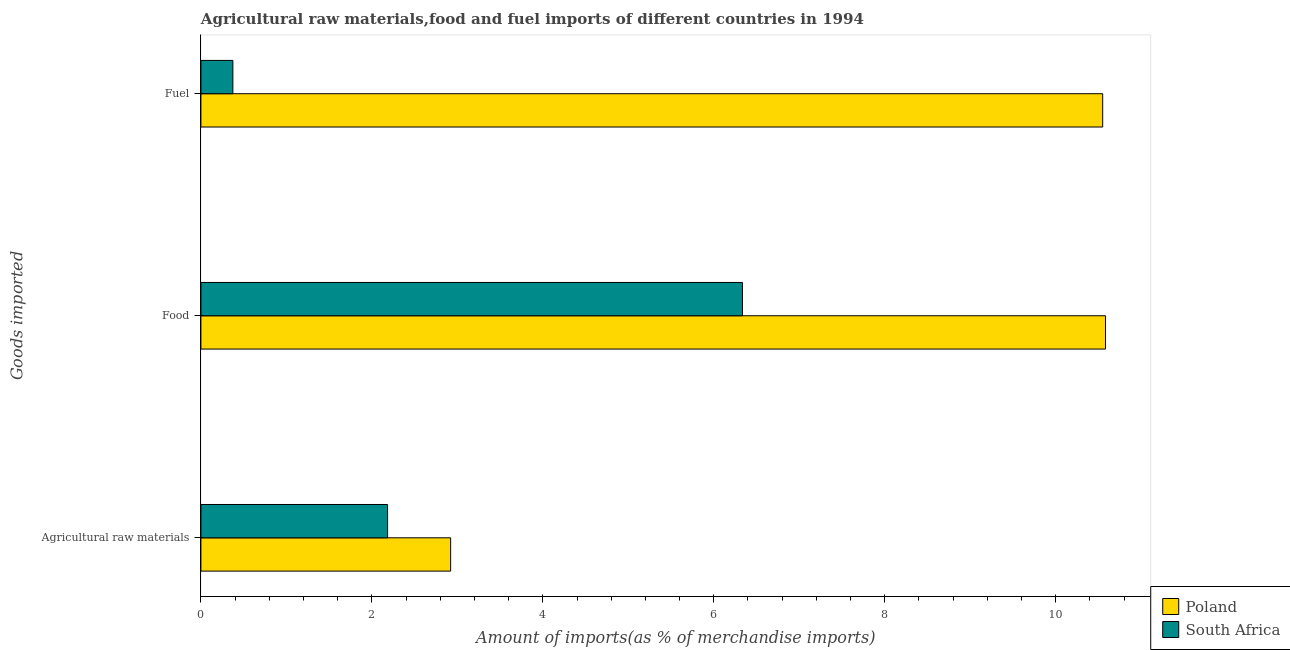What is the label of the 3rd group of bars from the top?
Your response must be concise. Agricultural raw materials. What is the percentage of fuel imports in South Africa?
Your answer should be compact. 0.37. Across all countries, what is the maximum percentage of fuel imports?
Give a very brief answer. 10.55. Across all countries, what is the minimum percentage of fuel imports?
Your answer should be very brief. 0.37. In which country was the percentage of raw materials imports minimum?
Give a very brief answer. South Africa. What is the total percentage of raw materials imports in the graph?
Your answer should be very brief. 5.11. What is the difference between the percentage of raw materials imports in Poland and that in South Africa?
Keep it short and to the point. 0.74. What is the difference between the percentage of food imports in South Africa and the percentage of fuel imports in Poland?
Ensure brevity in your answer.  -4.21. What is the average percentage of food imports per country?
Give a very brief answer. 8.46. What is the difference between the percentage of food imports and percentage of raw materials imports in Poland?
Ensure brevity in your answer.  7.66. What is the ratio of the percentage of fuel imports in South Africa to that in Poland?
Your response must be concise. 0.04. Is the difference between the percentage of fuel imports in South Africa and Poland greater than the difference between the percentage of raw materials imports in South Africa and Poland?
Your answer should be compact. No. What is the difference between the highest and the second highest percentage of food imports?
Give a very brief answer. 4.25. What is the difference between the highest and the lowest percentage of food imports?
Your response must be concise. 4.25. In how many countries, is the percentage of food imports greater than the average percentage of food imports taken over all countries?
Your answer should be compact. 1. Is the sum of the percentage of raw materials imports in Poland and South Africa greater than the maximum percentage of food imports across all countries?
Ensure brevity in your answer.  No. What does the 1st bar from the top in Agricultural raw materials represents?
Ensure brevity in your answer.  South Africa. Is it the case that in every country, the sum of the percentage of raw materials imports and percentage of food imports is greater than the percentage of fuel imports?
Provide a short and direct response. Yes. How many countries are there in the graph?
Give a very brief answer. 2. Does the graph contain grids?
Offer a very short reply. No. What is the title of the graph?
Your response must be concise. Agricultural raw materials,food and fuel imports of different countries in 1994. What is the label or title of the X-axis?
Keep it short and to the point. Amount of imports(as % of merchandise imports). What is the label or title of the Y-axis?
Keep it short and to the point. Goods imported. What is the Amount of imports(as % of merchandise imports) of Poland in Agricultural raw materials?
Ensure brevity in your answer.  2.92. What is the Amount of imports(as % of merchandise imports) in South Africa in Agricultural raw materials?
Offer a very short reply. 2.18. What is the Amount of imports(as % of merchandise imports) in Poland in Food?
Provide a short and direct response. 10.58. What is the Amount of imports(as % of merchandise imports) in South Africa in Food?
Provide a succinct answer. 6.34. What is the Amount of imports(as % of merchandise imports) of Poland in Fuel?
Give a very brief answer. 10.55. What is the Amount of imports(as % of merchandise imports) of South Africa in Fuel?
Offer a terse response. 0.37. Across all Goods imported, what is the maximum Amount of imports(as % of merchandise imports) in Poland?
Your response must be concise. 10.58. Across all Goods imported, what is the maximum Amount of imports(as % of merchandise imports) in South Africa?
Your answer should be very brief. 6.34. Across all Goods imported, what is the minimum Amount of imports(as % of merchandise imports) in Poland?
Ensure brevity in your answer.  2.92. Across all Goods imported, what is the minimum Amount of imports(as % of merchandise imports) of South Africa?
Provide a succinct answer. 0.37. What is the total Amount of imports(as % of merchandise imports) of Poland in the graph?
Offer a terse response. 24.05. What is the total Amount of imports(as % of merchandise imports) in South Africa in the graph?
Offer a very short reply. 8.89. What is the difference between the Amount of imports(as % of merchandise imports) of Poland in Agricultural raw materials and that in Food?
Your answer should be very brief. -7.66. What is the difference between the Amount of imports(as % of merchandise imports) in South Africa in Agricultural raw materials and that in Food?
Make the answer very short. -4.15. What is the difference between the Amount of imports(as % of merchandise imports) in Poland in Agricultural raw materials and that in Fuel?
Offer a very short reply. -7.63. What is the difference between the Amount of imports(as % of merchandise imports) in South Africa in Agricultural raw materials and that in Fuel?
Offer a very short reply. 1.81. What is the difference between the Amount of imports(as % of merchandise imports) of Poland in Food and that in Fuel?
Make the answer very short. 0.03. What is the difference between the Amount of imports(as % of merchandise imports) in South Africa in Food and that in Fuel?
Give a very brief answer. 5.96. What is the difference between the Amount of imports(as % of merchandise imports) of Poland in Agricultural raw materials and the Amount of imports(as % of merchandise imports) of South Africa in Food?
Provide a succinct answer. -3.41. What is the difference between the Amount of imports(as % of merchandise imports) in Poland in Agricultural raw materials and the Amount of imports(as % of merchandise imports) in South Africa in Fuel?
Provide a succinct answer. 2.55. What is the difference between the Amount of imports(as % of merchandise imports) of Poland in Food and the Amount of imports(as % of merchandise imports) of South Africa in Fuel?
Provide a short and direct response. 10.21. What is the average Amount of imports(as % of merchandise imports) of Poland per Goods imported?
Your response must be concise. 8.02. What is the average Amount of imports(as % of merchandise imports) of South Africa per Goods imported?
Ensure brevity in your answer.  2.96. What is the difference between the Amount of imports(as % of merchandise imports) of Poland and Amount of imports(as % of merchandise imports) of South Africa in Agricultural raw materials?
Your answer should be compact. 0.74. What is the difference between the Amount of imports(as % of merchandise imports) in Poland and Amount of imports(as % of merchandise imports) in South Africa in Food?
Make the answer very short. 4.25. What is the difference between the Amount of imports(as % of merchandise imports) in Poland and Amount of imports(as % of merchandise imports) in South Africa in Fuel?
Offer a very short reply. 10.18. What is the ratio of the Amount of imports(as % of merchandise imports) in Poland in Agricultural raw materials to that in Food?
Your response must be concise. 0.28. What is the ratio of the Amount of imports(as % of merchandise imports) in South Africa in Agricultural raw materials to that in Food?
Offer a very short reply. 0.34. What is the ratio of the Amount of imports(as % of merchandise imports) of Poland in Agricultural raw materials to that in Fuel?
Ensure brevity in your answer.  0.28. What is the ratio of the Amount of imports(as % of merchandise imports) in South Africa in Agricultural raw materials to that in Fuel?
Your answer should be compact. 5.84. What is the ratio of the Amount of imports(as % of merchandise imports) in Poland in Food to that in Fuel?
Make the answer very short. 1. What is the ratio of the Amount of imports(as % of merchandise imports) of South Africa in Food to that in Fuel?
Offer a very short reply. 16.94. What is the difference between the highest and the second highest Amount of imports(as % of merchandise imports) of Poland?
Your answer should be very brief. 0.03. What is the difference between the highest and the second highest Amount of imports(as % of merchandise imports) in South Africa?
Offer a terse response. 4.15. What is the difference between the highest and the lowest Amount of imports(as % of merchandise imports) in Poland?
Provide a short and direct response. 7.66. What is the difference between the highest and the lowest Amount of imports(as % of merchandise imports) of South Africa?
Give a very brief answer. 5.96. 